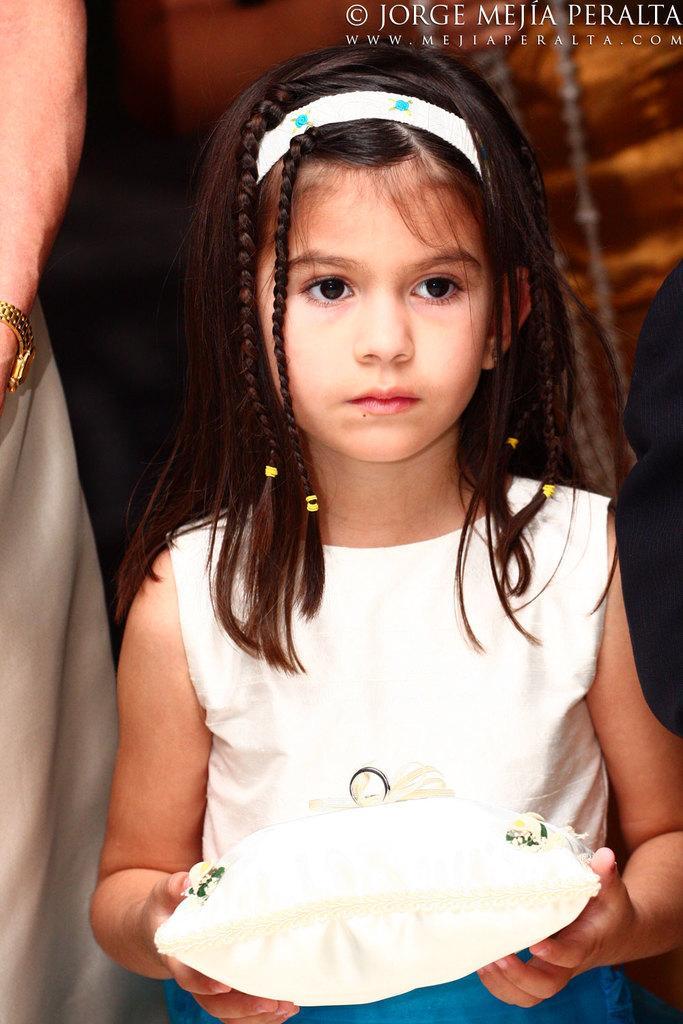In one or two sentences, can you explain what this image depicts? In this image there is a girl towards the bottom of the image, she is holding an object, there is a person towards the left of the image, there is an object towards the right of the image, there is an object behind the girl, there is text towards the top of the image. 